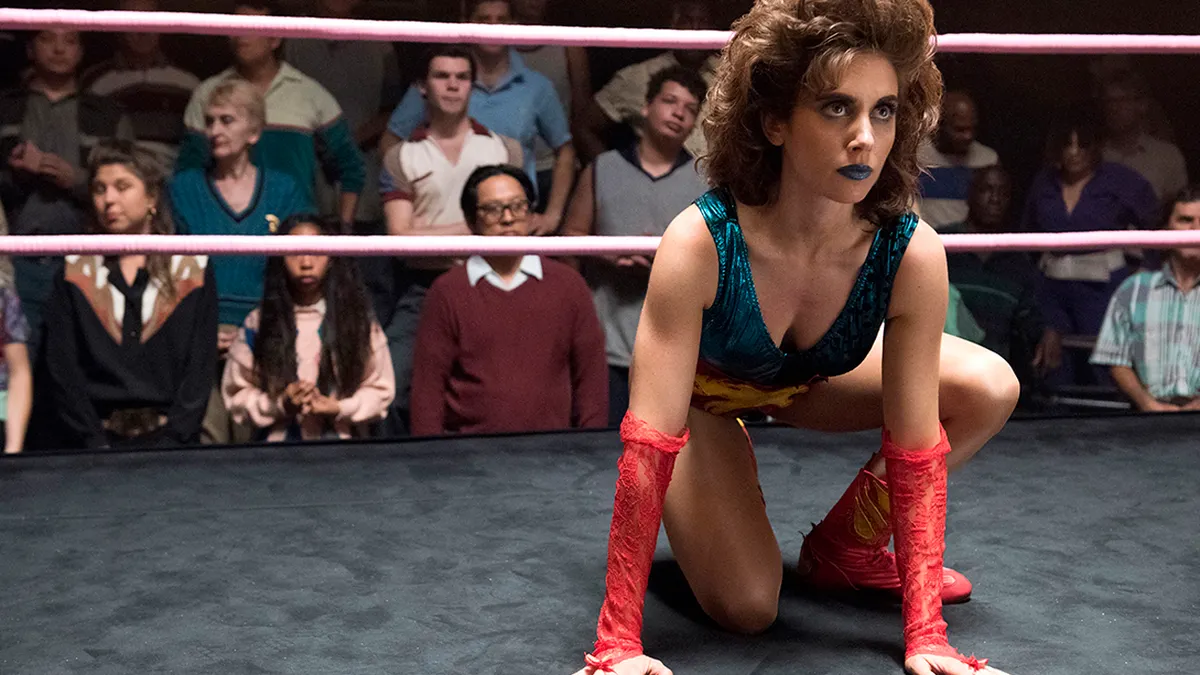What are the key elements in this picture? The image features a person in a wrestling ring assuming a poised and ready stance. The individual is dressed in a colorful metallic blue and red costume with matching red gloves, emphasizing their role as a wrestler in the ring. They exude an air of determination, evident in their focused expression. The background is brimming with an audience whose attention is fixed on the action in the ring, enhancing the feeling of a live, dynamic sporting event. 